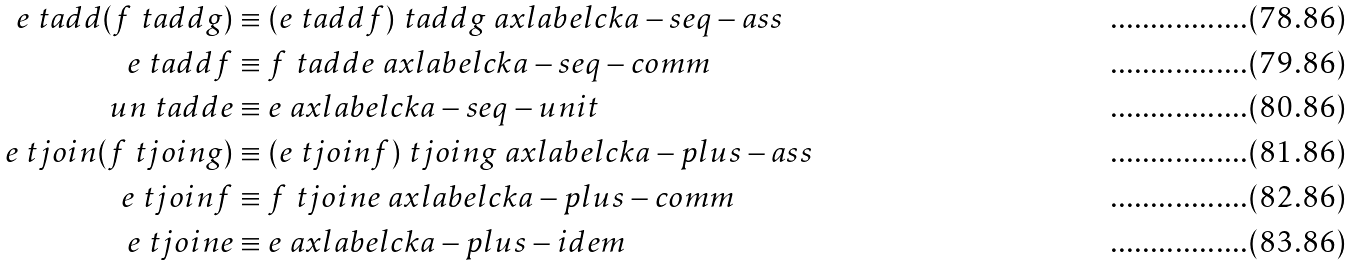Convert formula to latex. <formula><loc_0><loc_0><loc_500><loc_500>e \ t a d d ( f \ t a d d g ) & \equiv ( e \ t a d d f ) \ t a d d g \ a x l a b e l { c k a - s e q - a s s } \\ e \ t a d d f & \equiv f \ t a d d e \ a x l a b e l { c k a - s e q - c o m m } \\ \ u n \ t a d d e & \equiv e \ a x l a b e l { c k a - s e q - u n i t } \\ e \ t j o i n ( f \ t j o i n g ) & \equiv ( e \ t j o i n f ) \ t j o i n g \ a x l a b e l { c k a - p l u s - a s s } \\ e \ t j o i n f & \equiv f \ t j o i n e \ a x l a b e l { c k a - p l u s - c o m m } \\ e \ t j o i n e & \equiv e \ a x l a b e l { c k a - p l u s - i d e m }</formula> 